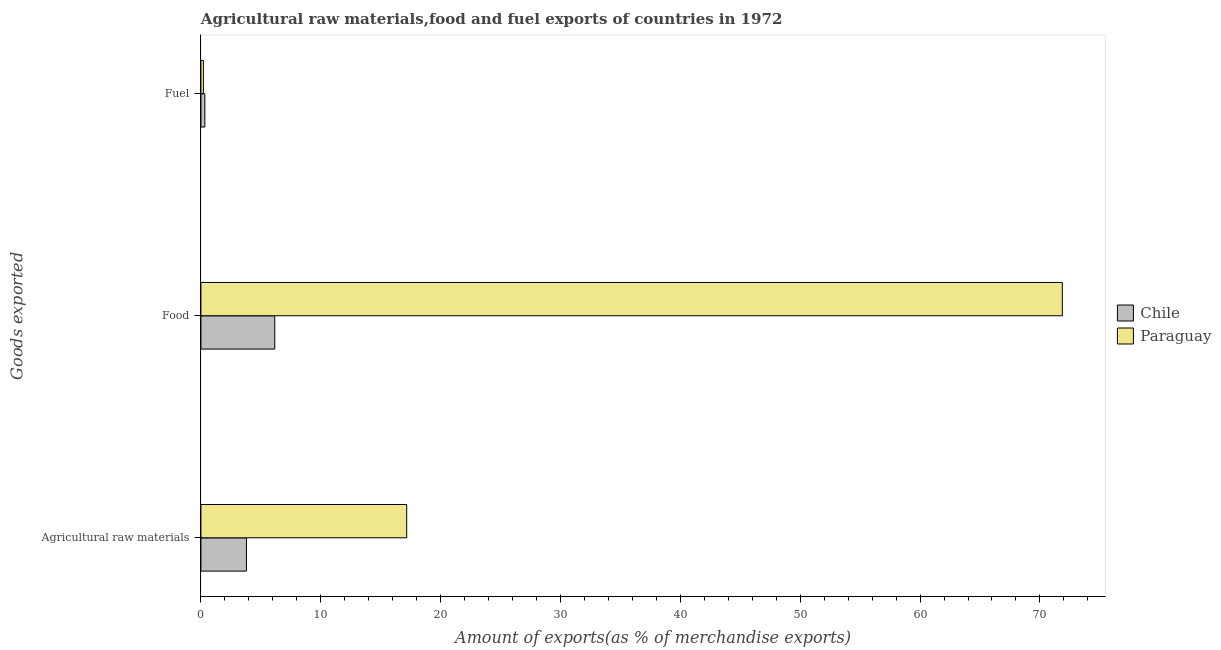How many different coloured bars are there?
Your response must be concise. 2. What is the label of the 2nd group of bars from the top?
Your response must be concise. Food. What is the percentage of fuel exports in Chile?
Provide a succinct answer. 0.33. Across all countries, what is the maximum percentage of fuel exports?
Your response must be concise. 0.33. Across all countries, what is the minimum percentage of fuel exports?
Offer a terse response. 0.21. In which country was the percentage of fuel exports minimum?
Your response must be concise. Paraguay. What is the total percentage of fuel exports in the graph?
Keep it short and to the point. 0.54. What is the difference between the percentage of food exports in Paraguay and that in Chile?
Your response must be concise. 65.71. What is the difference between the percentage of raw materials exports in Paraguay and the percentage of food exports in Chile?
Your answer should be very brief. 11.01. What is the average percentage of food exports per country?
Keep it short and to the point. 39.02. What is the difference between the percentage of raw materials exports and percentage of food exports in Paraguay?
Offer a terse response. -54.7. What is the ratio of the percentage of raw materials exports in Chile to that in Paraguay?
Offer a terse response. 0.22. What is the difference between the highest and the second highest percentage of raw materials exports?
Offer a terse response. 13.37. What is the difference between the highest and the lowest percentage of raw materials exports?
Your response must be concise. 13.37. Is the sum of the percentage of food exports in Paraguay and Chile greater than the maximum percentage of fuel exports across all countries?
Your answer should be very brief. Yes. What does the 2nd bar from the top in Food represents?
Your answer should be very brief. Chile. How many bars are there?
Your response must be concise. 6. What is the difference between two consecutive major ticks on the X-axis?
Provide a short and direct response. 10. Are the values on the major ticks of X-axis written in scientific E-notation?
Your response must be concise. No. What is the title of the graph?
Offer a very short reply. Agricultural raw materials,food and fuel exports of countries in 1972. Does "Cote d'Ivoire" appear as one of the legend labels in the graph?
Keep it short and to the point. No. What is the label or title of the X-axis?
Your answer should be very brief. Amount of exports(as % of merchandise exports). What is the label or title of the Y-axis?
Make the answer very short. Goods exported. What is the Amount of exports(as % of merchandise exports) of Chile in Agricultural raw materials?
Provide a succinct answer. 3.8. What is the Amount of exports(as % of merchandise exports) in Paraguay in Agricultural raw materials?
Offer a very short reply. 17.17. What is the Amount of exports(as % of merchandise exports) in Chile in Food?
Your answer should be very brief. 6.16. What is the Amount of exports(as % of merchandise exports) in Paraguay in Food?
Your answer should be very brief. 71.87. What is the Amount of exports(as % of merchandise exports) in Chile in Fuel?
Make the answer very short. 0.33. What is the Amount of exports(as % of merchandise exports) in Paraguay in Fuel?
Your answer should be very brief. 0.21. Across all Goods exported, what is the maximum Amount of exports(as % of merchandise exports) in Chile?
Offer a very short reply. 6.16. Across all Goods exported, what is the maximum Amount of exports(as % of merchandise exports) of Paraguay?
Offer a very short reply. 71.87. Across all Goods exported, what is the minimum Amount of exports(as % of merchandise exports) in Chile?
Ensure brevity in your answer.  0.33. Across all Goods exported, what is the minimum Amount of exports(as % of merchandise exports) in Paraguay?
Provide a short and direct response. 0.21. What is the total Amount of exports(as % of merchandise exports) in Chile in the graph?
Provide a succinct answer. 10.29. What is the total Amount of exports(as % of merchandise exports) in Paraguay in the graph?
Provide a short and direct response. 89.24. What is the difference between the Amount of exports(as % of merchandise exports) of Chile in Agricultural raw materials and that in Food?
Provide a succinct answer. -2.36. What is the difference between the Amount of exports(as % of merchandise exports) in Paraguay in Agricultural raw materials and that in Food?
Keep it short and to the point. -54.7. What is the difference between the Amount of exports(as % of merchandise exports) in Chile in Agricultural raw materials and that in Fuel?
Your answer should be very brief. 3.47. What is the difference between the Amount of exports(as % of merchandise exports) of Paraguay in Agricultural raw materials and that in Fuel?
Offer a very short reply. 16.96. What is the difference between the Amount of exports(as % of merchandise exports) of Chile in Food and that in Fuel?
Ensure brevity in your answer.  5.83. What is the difference between the Amount of exports(as % of merchandise exports) in Paraguay in Food and that in Fuel?
Ensure brevity in your answer.  71.66. What is the difference between the Amount of exports(as % of merchandise exports) in Chile in Agricultural raw materials and the Amount of exports(as % of merchandise exports) in Paraguay in Food?
Ensure brevity in your answer.  -68.07. What is the difference between the Amount of exports(as % of merchandise exports) in Chile in Agricultural raw materials and the Amount of exports(as % of merchandise exports) in Paraguay in Fuel?
Offer a very short reply. 3.59. What is the difference between the Amount of exports(as % of merchandise exports) in Chile in Food and the Amount of exports(as % of merchandise exports) in Paraguay in Fuel?
Your answer should be very brief. 5.95. What is the average Amount of exports(as % of merchandise exports) of Chile per Goods exported?
Make the answer very short. 3.43. What is the average Amount of exports(as % of merchandise exports) in Paraguay per Goods exported?
Give a very brief answer. 29.75. What is the difference between the Amount of exports(as % of merchandise exports) in Chile and Amount of exports(as % of merchandise exports) in Paraguay in Agricultural raw materials?
Your answer should be compact. -13.37. What is the difference between the Amount of exports(as % of merchandise exports) of Chile and Amount of exports(as % of merchandise exports) of Paraguay in Food?
Give a very brief answer. -65.71. What is the difference between the Amount of exports(as % of merchandise exports) in Chile and Amount of exports(as % of merchandise exports) in Paraguay in Fuel?
Ensure brevity in your answer.  0.12. What is the ratio of the Amount of exports(as % of merchandise exports) in Chile in Agricultural raw materials to that in Food?
Your answer should be very brief. 0.62. What is the ratio of the Amount of exports(as % of merchandise exports) in Paraguay in Agricultural raw materials to that in Food?
Your answer should be compact. 0.24. What is the ratio of the Amount of exports(as % of merchandise exports) in Chile in Agricultural raw materials to that in Fuel?
Provide a short and direct response. 11.58. What is the ratio of the Amount of exports(as % of merchandise exports) in Paraguay in Agricultural raw materials to that in Fuel?
Keep it short and to the point. 82.57. What is the ratio of the Amount of exports(as % of merchandise exports) in Chile in Food to that in Fuel?
Offer a very short reply. 18.79. What is the ratio of the Amount of exports(as % of merchandise exports) of Paraguay in Food to that in Fuel?
Make the answer very short. 345.69. What is the difference between the highest and the second highest Amount of exports(as % of merchandise exports) in Chile?
Keep it short and to the point. 2.36. What is the difference between the highest and the second highest Amount of exports(as % of merchandise exports) in Paraguay?
Your answer should be compact. 54.7. What is the difference between the highest and the lowest Amount of exports(as % of merchandise exports) in Chile?
Your answer should be very brief. 5.83. What is the difference between the highest and the lowest Amount of exports(as % of merchandise exports) of Paraguay?
Provide a succinct answer. 71.66. 